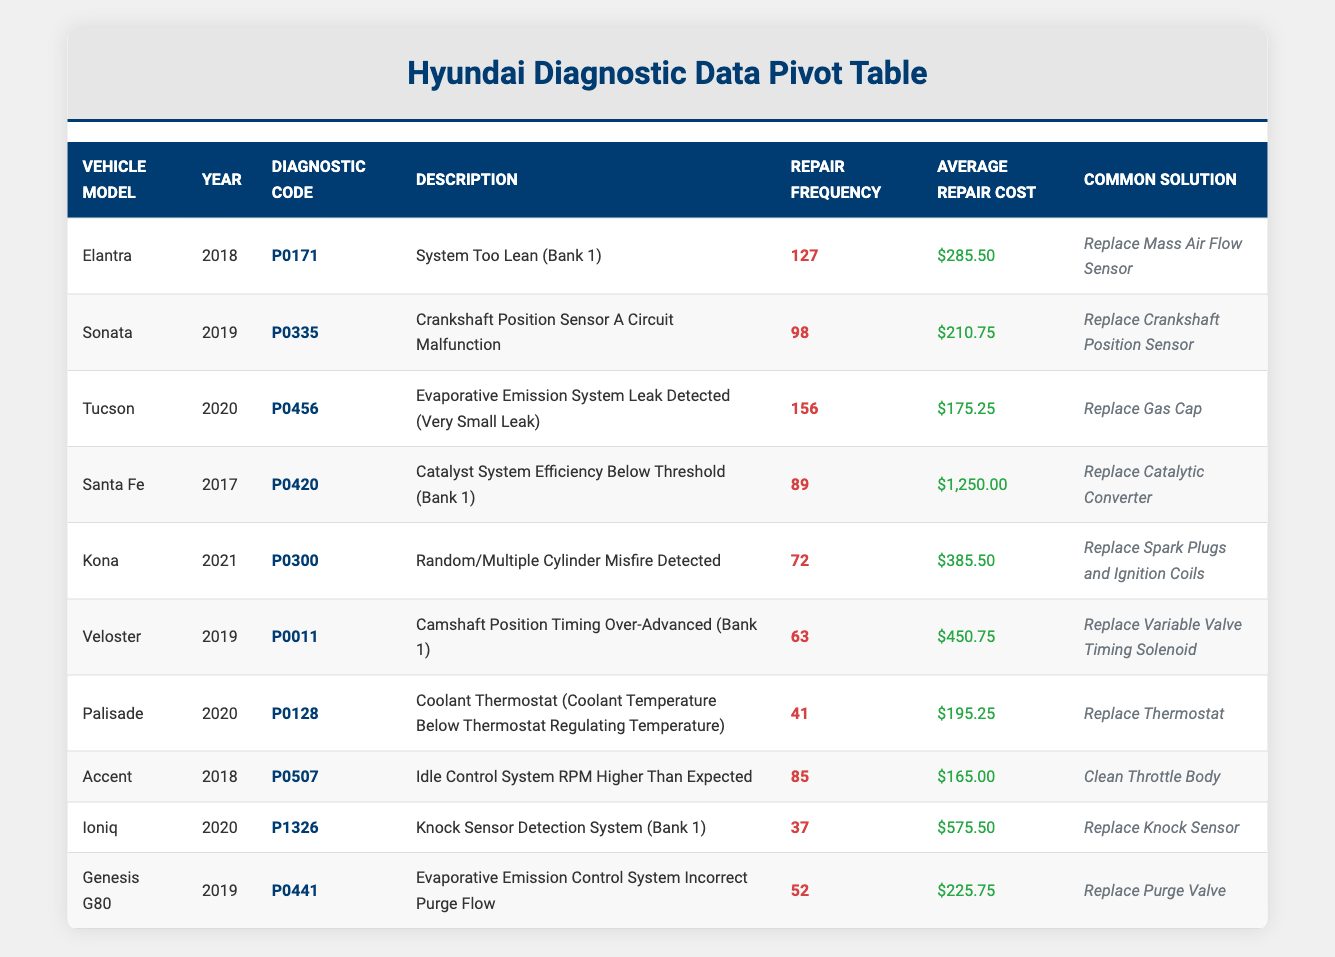What is the repair frequency for the Tucson? The Tucson's repair frequency is listed directly in the table under the corresponding vehicle model. It shows a value of 156.
Answer: 156 What is the average repair cost for the Elantra? The average repair cost for the Elantra is indicated in the table next to its repair frequency. It shows $285.50.
Answer: $285.50 Which vehicle model has the highest average repair cost? By examining the average repair costs in the table, the Santa Fe has the highest value at $1,250.00.
Answer: Santa Fe Are there any vehicles with a repair frequency of 100 or more? To find if any vehicles meet this criterion, we check the frequency values for each vehicle. Tucson (156), Elantra (127), and Sonata (98) show 100 or more.
Answer: Yes What is the combined repair frequency for models produced in 2019? First, we identify the models from 2019: Sonata (98), Veloster (63), and Genesis G80 (52). We then sum these frequencies: 98 + 63 + 52 = 213.
Answer: 213 How many vehicle models reported a repair frequency lower than 50? Reviewing all listed frequencies, we see the Palisade has the lowest frequency of 41. Since it’s the only vehicle listed below 50, the count is 1.
Answer: 1 What is the average repair cost for vehicles with a diagnostic code starting with "P0"? We first list the relevant vehicles with 'P0' codes: Elantra, Sonata, Tucson, and Santa Fe, with costs of $285.50, $210.75, $175.25, and $1,250.00 respectively. The average is then calculated: (285.50 + 210.75 + 175.25 + 1,250) / 4 = $485.13.
Answer: $485.13 Is it true that all models from 2020 have a repair frequency of less than 100? Checking the relevant models from 2020: Tucson (156), Palisade (41), and Ioniq (37), it is evident that the Tucson has a frequency above 100.
Answer: No What is the total number of repairs reported across all models presented? We need to sum the repair frequencies for each vehicle model in the table. Adding all listed frequencies gives: 127 + 98 + 156 + 89 + 72 + 63 + 41 + 85 + 37 + 52 =  819.
Answer: 819 